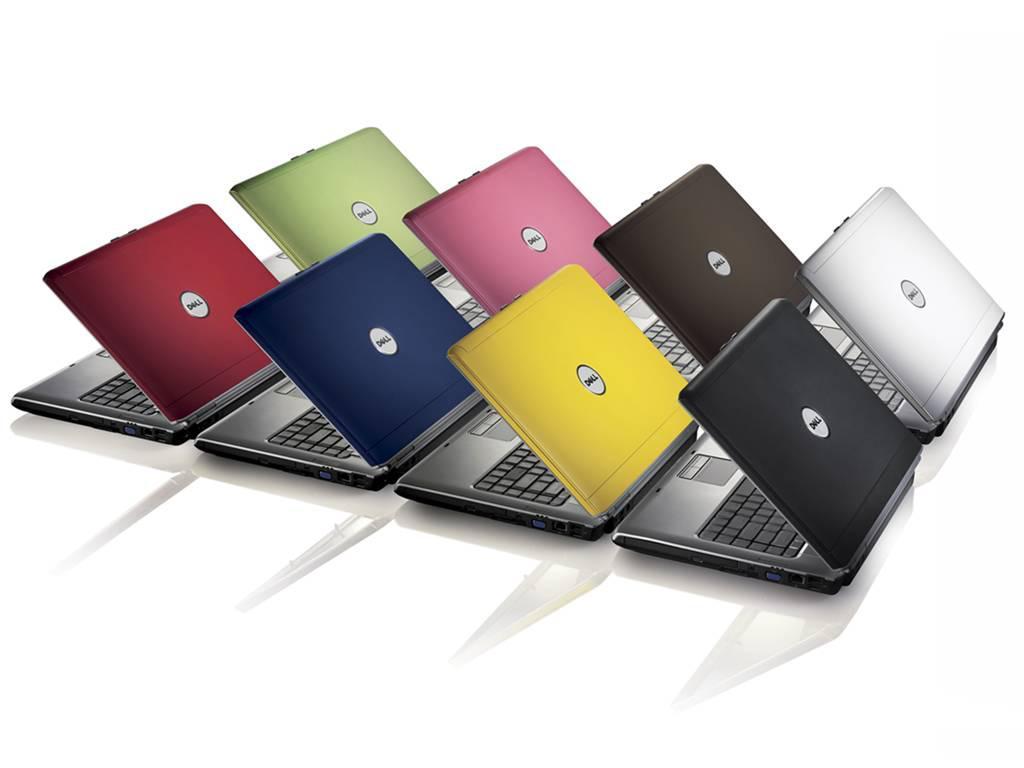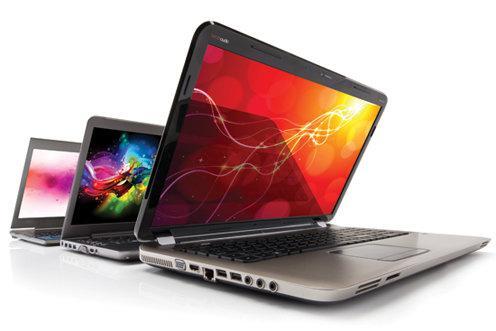The first image is the image on the left, the second image is the image on the right. Given the left and right images, does the statement "The right and left images contain the same number of laptops." hold true? Answer yes or no. No. The first image is the image on the left, the second image is the image on the right. For the images displayed, is the sentence "One of the images contains exactly three computers" factually correct? Answer yes or no. Yes. 